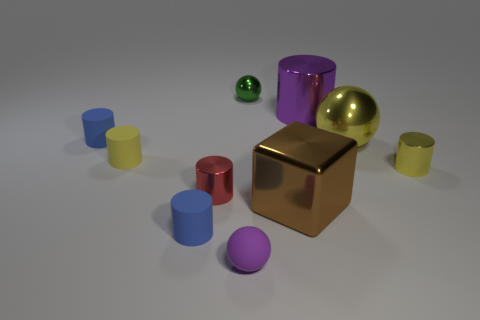How big is the purple matte sphere in front of the brown metallic block?
Give a very brief answer. Small. There is a purple rubber ball that is in front of the big yellow thing; is there a blue matte thing in front of it?
Your response must be concise. No. There is a tiny shiny cylinder that is to the right of the metallic cube; is it the same color as the cylinder in front of the tiny red thing?
Keep it short and to the point. No. The big metal sphere has what color?
Your answer should be compact. Yellow. Is there anything else that has the same color as the big cube?
Make the answer very short. No. There is a shiny cylinder that is both in front of the big yellow object and on the left side of the big yellow metal object; what is its color?
Offer a very short reply. Red. Do the red metallic cylinder on the left side of the green object and the big purple cylinder have the same size?
Provide a succinct answer. No. Is the number of tiny red cylinders behind the green metallic thing greater than the number of tiny rubber things?
Provide a short and direct response. No. Does the brown shiny object have the same shape as the small purple object?
Ensure brevity in your answer.  No. The metallic block is what size?
Your answer should be compact. Large. 